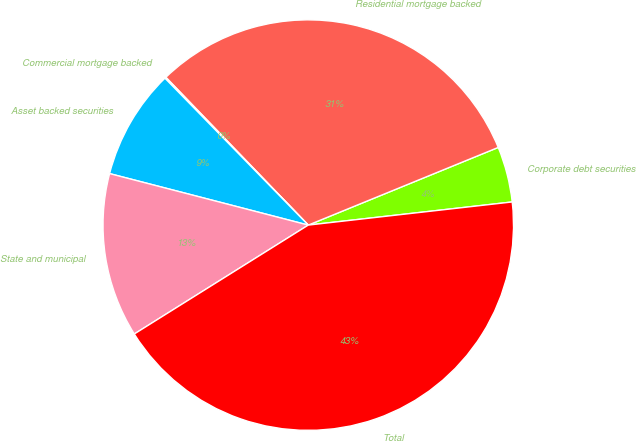Convert chart. <chart><loc_0><loc_0><loc_500><loc_500><pie_chart><fcel>Corporate debt securities<fcel>Residential mortgage backed<fcel>Commercial mortgage backed<fcel>Asset backed securities<fcel>State and municipal<fcel>Total<nl><fcel>4.38%<fcel>31.03%<fcel>0.1%<fcel>8.66%<fcel>12.94%<fcel>42.9%<nl></chart> 